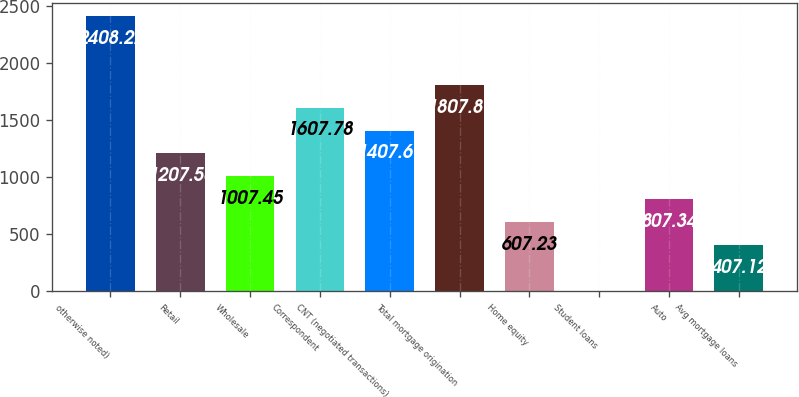Convert chart. <chart><loc_0><loc_0><loc_500><loc_500><bar_chart><fcel>otherwise noted)<fcel>Retail<fcel>Wholesale<fcel>Correspondent<fcel>CNT (negotiated transactions)<fcel>Total mortgage origination<fcel>Home equity<fcel>Student loans<fcel>Auto<fcel>Avg mortgage loans<nl><fcel>2408.22<fcel>1207.56<fcel>1007.45<fcel>1607.78<fcel>1407.67<fcel>1807.89<fcel>607.23<fcel>6.9<fcel>807.34<fcel>407.12<nl></chart> 